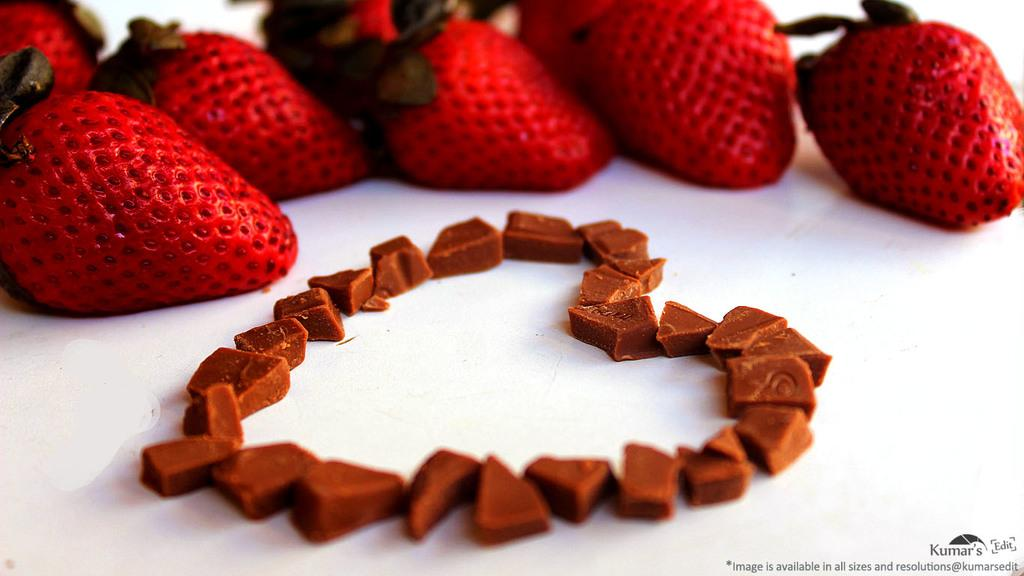What type of fruit is present in the image? There are red color strawberries in the image. What are the small pieces in the image? The small pieces in the image are brown in color. What is the color of the table in the image? The table in the image is white in color. How does the division of the strawberries affect the selection process in the image? There is no division or selection process mentioned or depicted in the image, as it only shows strawberries and small brown pieces on a white table. 